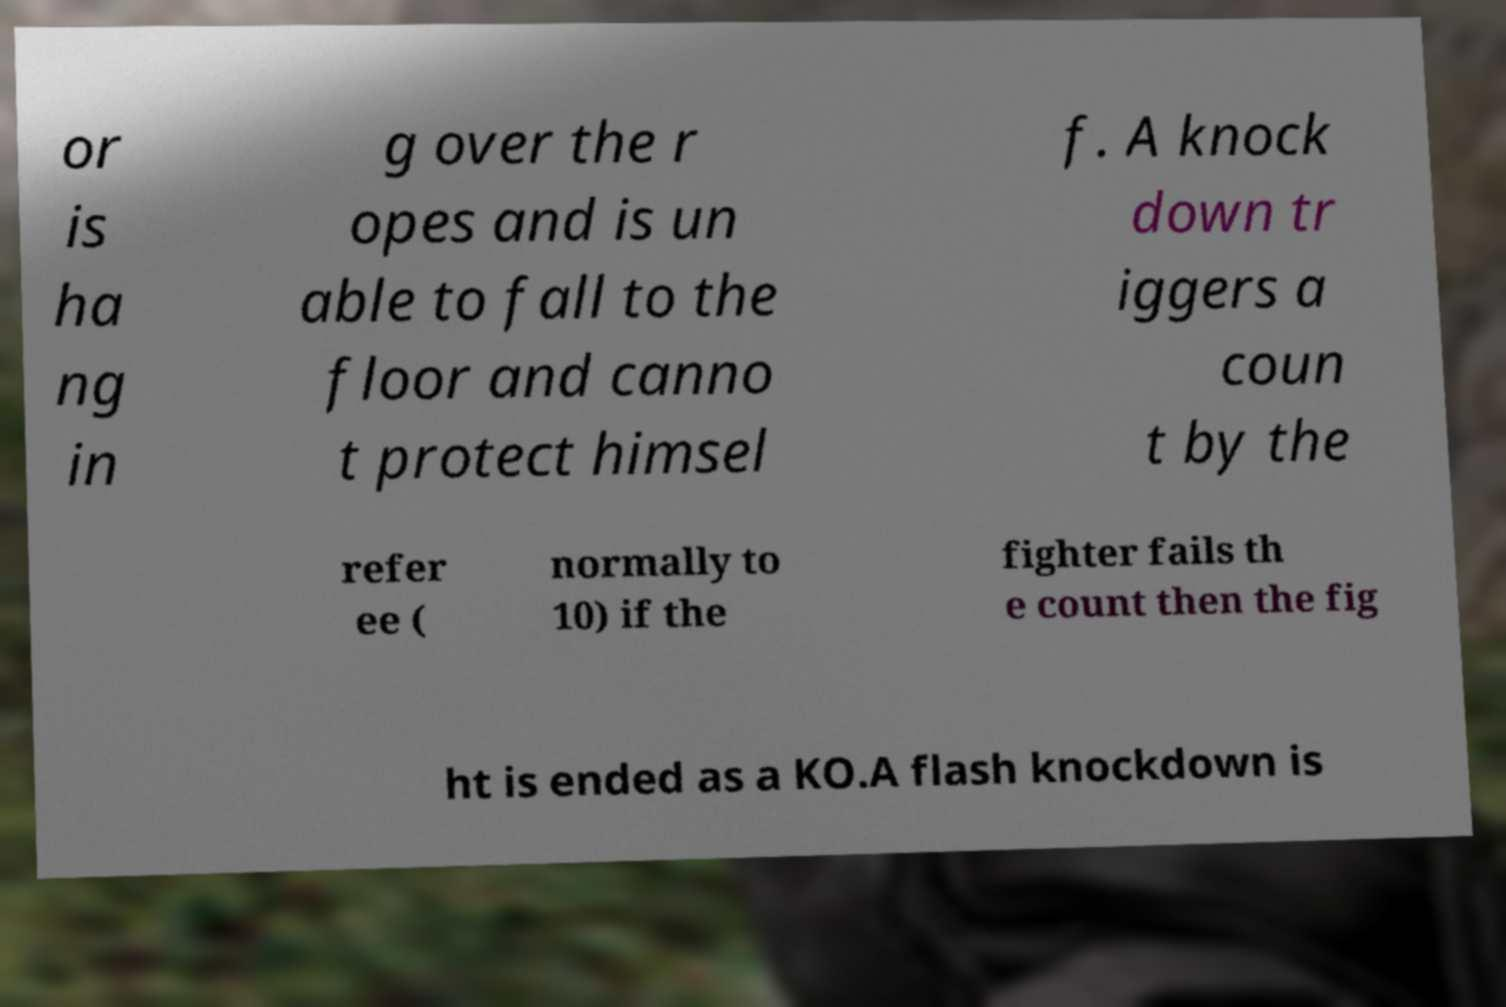Please read and relay the text visible in this image. What does it say? or is ha ng in g over the r opes and is un able to fall to the floor and canno t protect himsel f. A knock down tr iggers a coun t by the refer ee ( normally to 10) if the fighter fails th e count then the fig ht is ended as a KO.A flash knockdown is 